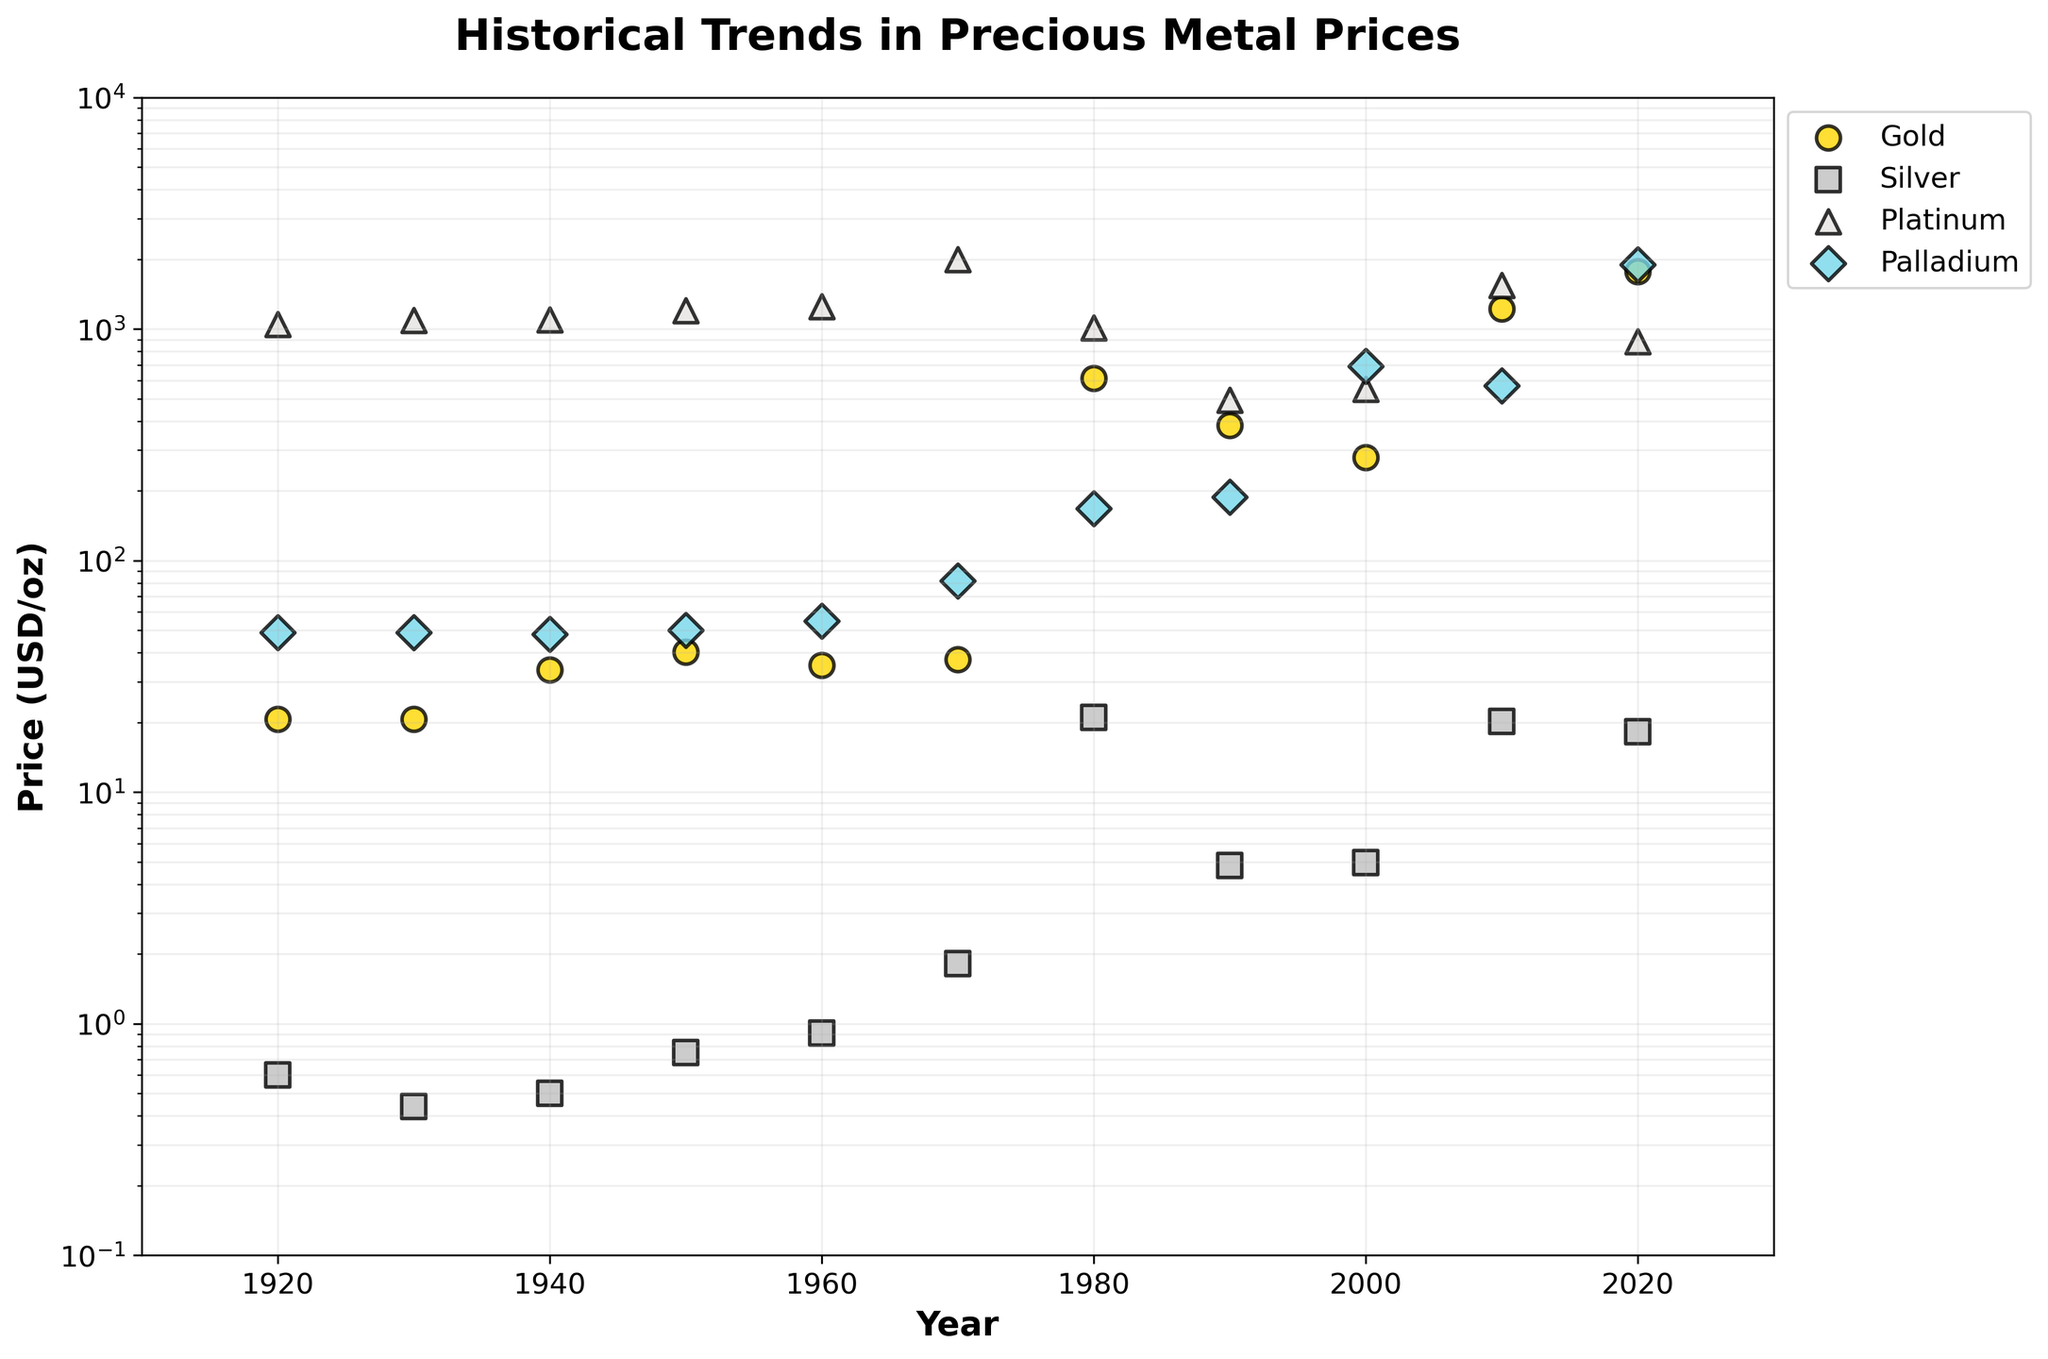What is the title of the scatter plot? The title is located at the top center of the scatter plot. It describes what the figure is about.
Answer: Historical Trends in Precious Metal Prices What are the labels on the axes? The labels are positioned along the x-axis and y-axis. They describe what each axis represents, making it clear what the graph's data points correlate to in real-world terms.
Answer: Year (x-axis), Price (USD/oz) (y-axis) How many different metals are represented in the scatter plot? Identify the different markers and colors used in the scatter plot. Each distinct marker and color represents a unique metal. The legend also aids in this identification.
Answer: Four Which metal had the highest price in 2020? Look at the data points corresponding to the year 2020 and identify the metal with the highest position on the y-axis.
Answer: Palladium What was the approximate price of gold in 1980? Find the data point for gold (usually indicated by a specific marker and color) at the year 1980 and read its y-axis value.
Answer: 614.75 USD/oz Between which two consecutive decades did silver see the most significant price increase? Check the y-axis positions for silver in each decade and calculate the differences to find the largest increase.
Answer: 1960 to 1980 Which metal shows the most significant fluctuation in price over the century? Compare the range of y-axis values for each metal over the years. The metal with the largest range has the most significant fluctuation.
Answer: Gold In which decade did platinum experience its highest price? Look at the data points for platinum and identify the highest position along the y-axis, then determine the corresponding decade.
Answer: 1970s Does any metal's price show a consistent upward trend over the century without any significant decline? Observe the data points for each metal and see if there is a steady increase without noticeable drops over the years.
Answer: No Comparing the price of palladium in 1970 and 2020, what is the factor of increase? Divide the price of palladium in 2020 by its price in 1970 to determine the multiplication factor.
Answer: 1900/82 ≈ 23.17 